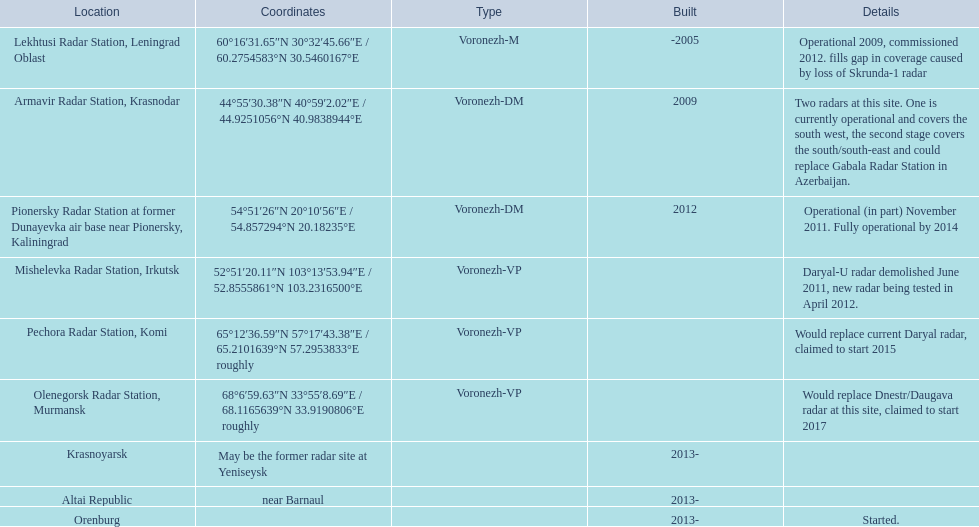Where is each radar? Lekhtusi Radar Station, Leningrad Oblast, Armavir Radar Station, Krasnodar, Pionersky Radar Station at former Dunayevka air base near Pionersky, Kaliningrad, Mishelevka Radar Station, Irkutsk, Pechora Radar Station, Komi, Olenegorsk Radar Station, Murmansk, Krasnoyarsk, Altai Republic, Orenburg. What are the details of each radar? Operational 2009, commissioned 2012. fills gap in coverage caused by loss of Skrunda-1 radar, Two radars at this site. One is currently operational and covers the south west, the second stage covers the south/south-east and could replace Gabala Radar Station in Azerbaijan., Operational (in part) November 2011. Fully operational by 2014, Daryal-U radar demolished June 2011, new radar being tested in April 2012., Would replace current Daryal radar, claimed to start 2015, Would replace Dnestr/Daugava radar at this site, claimed to start 2017, , , Started. Which radar is detailed to start in 2015? Pechora Radar Station, Komi. 